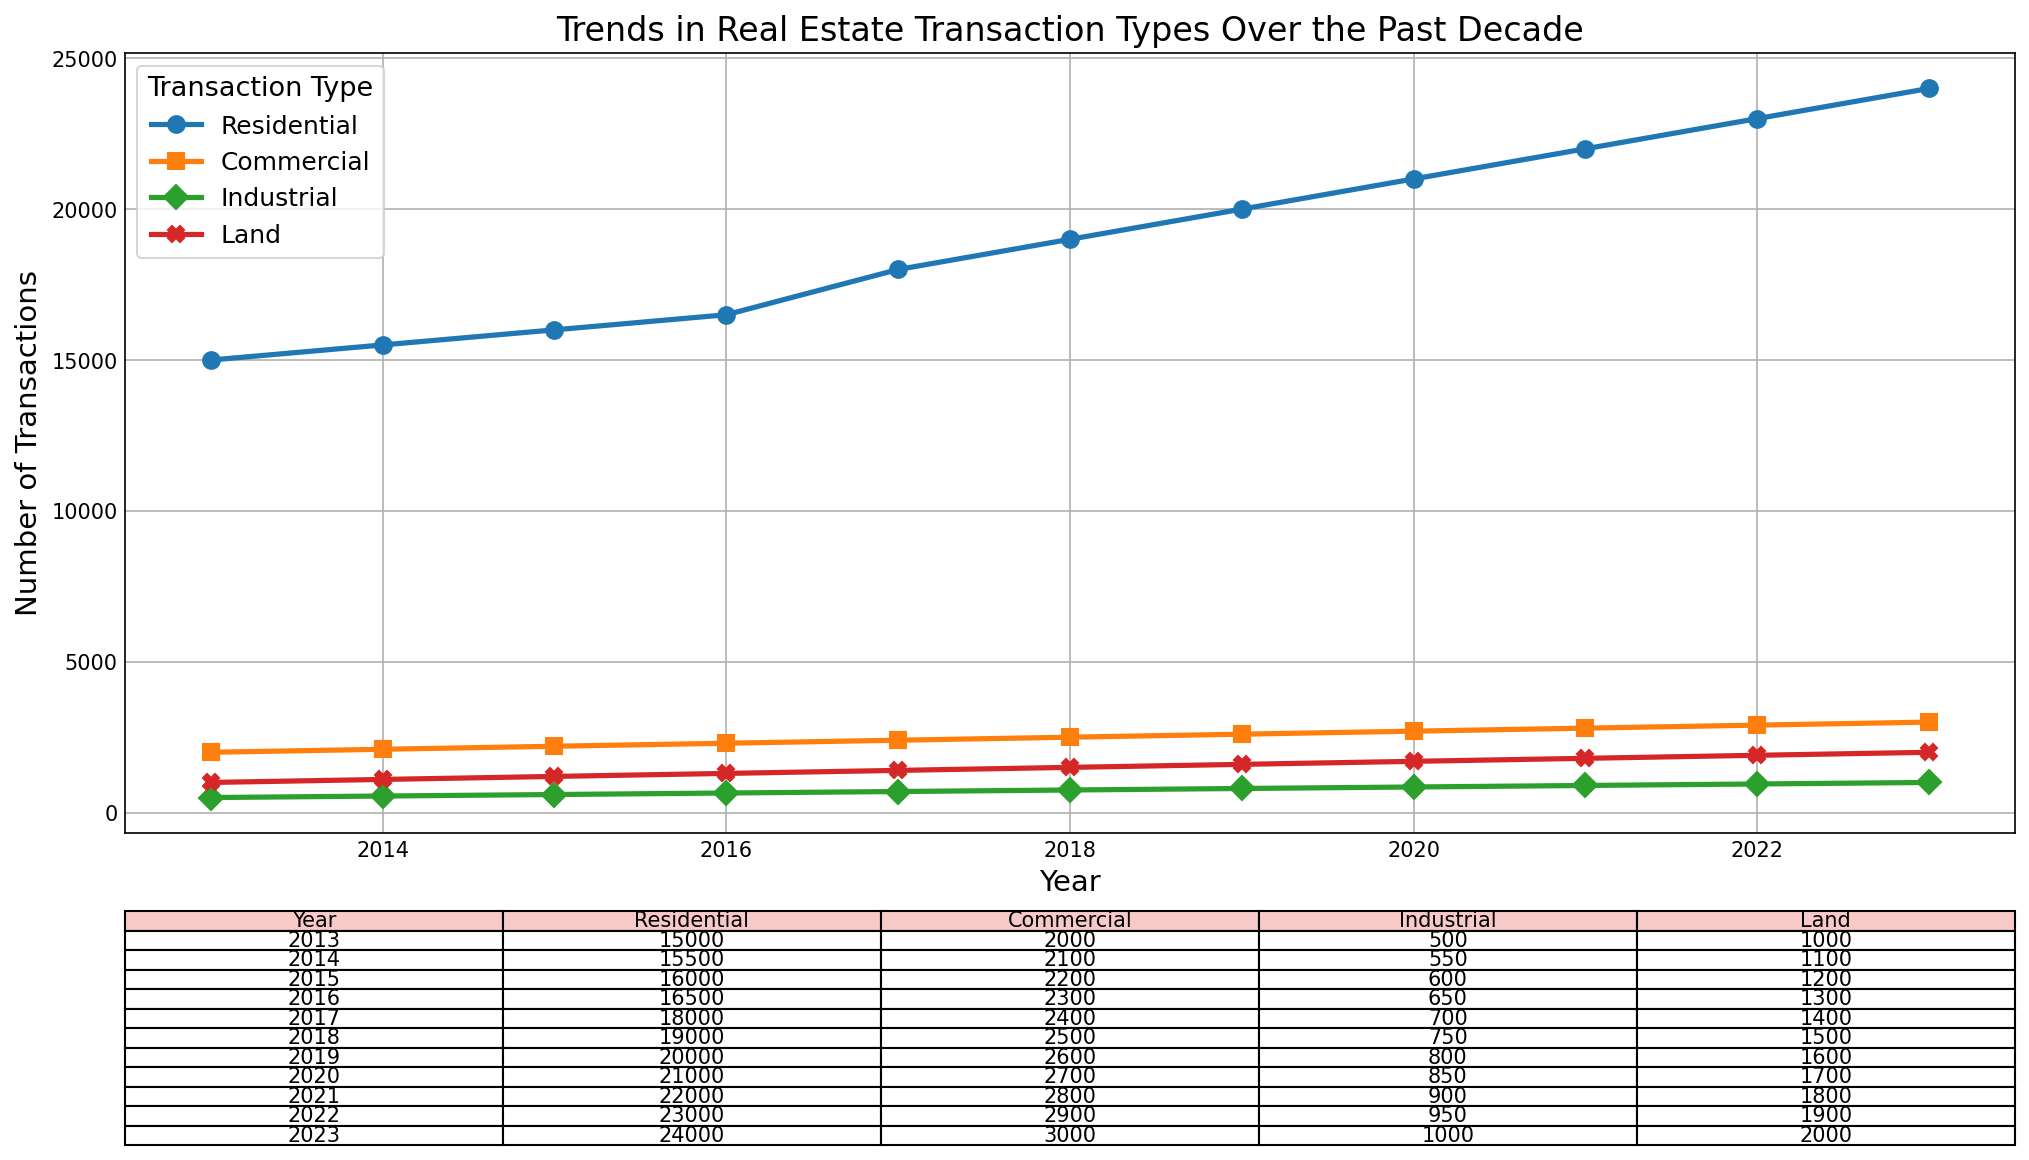What type of real estate transaction had the most significant increase in the number of transactions from 2013 to 2023? Compare the number of transactions in 2013 and 2023 for each type available in the plot. Calculate the difference: 
- Residential: 24000 - 15000 = 9000
- Commercial: 3000 - 2000 = 1000
- Industrial: 1000 - 500 = 500
- Land: 2000 - 1000 = 1000
The largest increase is in the Residential category.
Answer: Residential Which year showed the highest number of transactions for the Industrial type? Look at the Industrial line on the plot and see where it reaches its highest point. The highest value on the Industrial line corresponds to the year 2023.
Answer: 2023 In which year did the number of Land transactions reach 1600? Identify the value of 1600 on the Land line (red) in the plot and find the corresponding year below it. This occurs in the year 2019.
Answer: 2019 What is the average number of Residential transactions over the decade? Sum the Residential values from 2013 to 2023 and then divide by the number of years (11). 
Calculations:
(15000 + 15500 + 16000 + 16500 + 18000 + 19000 + 20000 + 21000 + 22000 + 23000 + 24000) / 11 = 2000. This equals 19100.
Answer: 19100 In 2018, what was the difference between the number of Residential and Commercial transactions? Subtract the number of Commercial transactions from Residential transactions for the year 2018: 
19000 - 2500 = 16500.
Answer: 16500 Which transaction type has shown a steady increase every year from 2013 to 2023 without any dips? Observe the plot and note the lines that do not decline at any point between 2013 and 2023. Both the Residential and Commercial lines continuously rise without any dips.
Answer: Residential, Commercial 